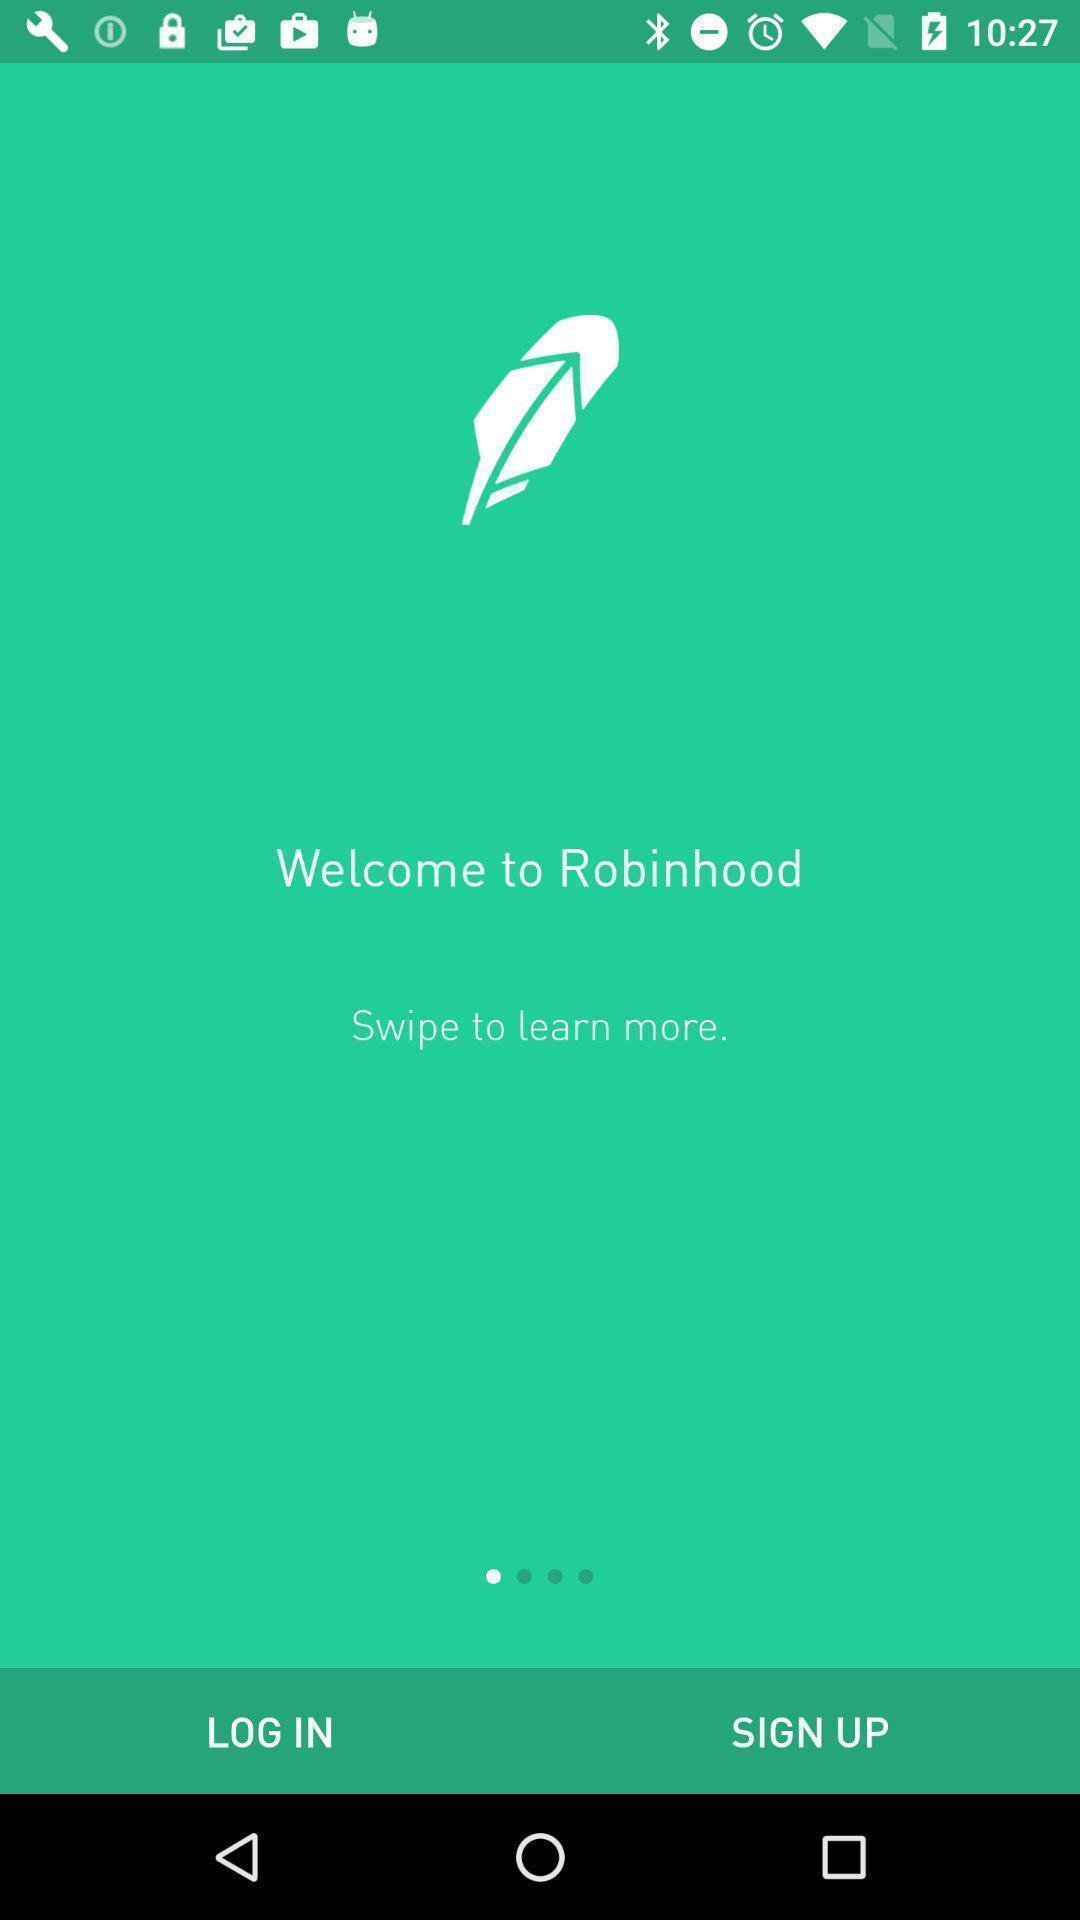Describe this image in words. Welcome page showing of login and sing up. 